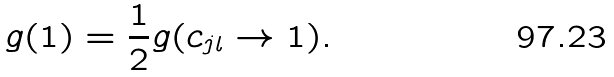Convert formula to latex. <formula><loc_0><loc_0><loc_500><loc_500>g ( 1 ) = \frac { 1 } { 2 } g ( c _ { j l } \rightarrow 1 ) .</formula> 